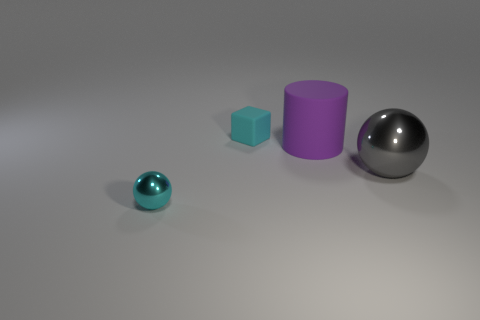Are the big gray sphere and the cyan cube made of the same material?
Offer a terse response. No. Are there the same number of large purple objects that are in front of the big purple rubber thing and large gray metal things that are behind the small cyan matte block?
Offer a very short reply. Yes. There is a tiny cyan object that is the same shape as the gray metal thing; what material is it?
Offer a very short reply. Metal. There is a metallic thing behind the cyan object that is in front of the cyan thing that is behind the big gray metallic sphere; what shape is it?
Keep it short and to the point. Sphere. Are there more matte cylinders that are behind the cyan block than cyan rubber objects?
Your answer should be very brief. No. There is a tiny thing in front of the large metallic thing; is it the same shape as the cyan matte thing?
Make the answer very short. No. There is a object on the left side of the small cyan rubber object; what is it made of?
Your answer should be very brief. Metal. What number of small cyan rubber things are the same shape as the purple rubber object?
Your answer should be very brief. 0. There is a small object that is behind the sphere that is to the left of the matte cylinder; what is its material?
Your response must be concise. Rubber. What shape is the rubber object that is the same color as the small metal object?
Keep it short and to the point. Cube. 